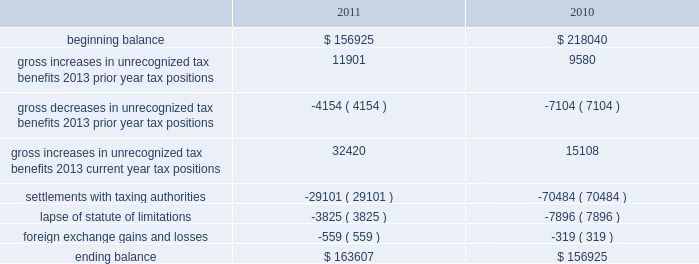A valuation allowance has been established for certain deferred tax assets related to the impairment of investments .
Accounting for uncertainty in income taxes during fiscal 2011 and 2010 , our aggregate changes in our total gross amount of unrecognized tax benefits are summarized as follows ( in thousands ) : beginning balance gross increases in unrecognized tax benefits 2013 prior year tax positions gross decreases in unrecognized tax benefits 2013 prior year tax positions gross increases in unrecognized tax benefits 2013 current year tax positions settlements with taxing authorities lapse of statute of limitations foreign exchange gains and losses ending balance $ 156925 11901 ( 4154 ) 32420 ( 29101 ) ( 3825 ) $ 163607 $ 218040 ( 7104 ) 15108 ( 70484 ) ( 7896 ) $ 156925 as of december 2 , 2011 , the combined amount of accrued interest and penalties related to tax positions taken on our tax returns and included in non-current income taxes payable was approximately $ 12.3 million .
We file income tax returns in the u.s .
On a federal basis and in many u.s .
State and foreign jurisdictions .
We are subject to the continual examination of our income tax returns by the irs and other domestic and foreign tax authorities .
Our major tax jurisdictions are the u.s. , ireland and california .
For california , ireland and the u.s. , the earliest fiscal years open for examination are 2005 , 2006 and 2008 , respectively .
We regularly assess the likelihood of outcomes resulting from these examinations to determine the adequacy of our provision for income taxes and have reserved for potential adjustments that may result from the current examination .
We believe such estimates to be reasonable ; however , there can be no assurance that the final determination of any of these examinations will not have an adverse effect on our operating results and financial position .
In august 2011 , a canadian income tax examination covering our fiscal years 2005 through 2008 was completed .
Our accrued tax and interest related to these years was approximately $ 35 million and was previously reported in long-term income taxes payable .
We reclassified approximately $ 17 million to short-term income taxes payable and decreased deferred tax assets by approximately $ 18 million in conjunction with the aforementioned resolution .
The $ 17 million balance in short-term income taxes payable is partially secured by a letter of credit and is expected to be paid by the first quarter of fiscal 2012 .
In october 2010 , a u.s .
Income tax examination covering our fiscal years 2005 through 2007 was completed .
Our accrued tax and interest related to these years was $ 59 million and was previously reported in long-term income taxes payable .
We paid $ 20 million in conjunction with the aforementioned resolution .
A net income statement tax benefit in the fourth quarter of fiscal 2010 of $ 39 million resulted .
The timing of the resolution of income tax examinations is highly uncertain as are the amounts and timing of tax payments that are part of any audit settlement process .
These events could cause large fluctuations in the balance sheet classification of current and non-current assets and liabilities .
The company believes that before the end of fiscal 2012 , it is reasonably possible that either certain audits will conclude or statutes of limitations on certain income tax examination periods will expire , or both .
Given the uncertainties described above , we can only determine a range of estimated potential decreases in underlying unrecognized tax benefits ranging from $ 0 to approximately $ 40 million .
These amounts would decrease income tax expense under current gaap related to income taxes .
Note 11 .
Restructuring fiscal 2011 restructuring plan in the fourth quarter of fiscal 2011 , in order to better align our resources around our digital media and digital marketing strategies , we initiated a restructuring plan consisting of reductions of approximately 700 full-time positions worldwide and we recorded restructuring charges of approximately $ 78.6 million related to ongoing termination benefits for the position eliminated .
Table of contents adobe systems incorporated notes to consolidated financial statements ( continued ) .
A valuation allowance has been established for certain deferred tax assets related to the impairment of investments .
Accounting for uncertainty in income taxes during fiscal 2011 and 2010 , our aggregate changes in our total gross amount of unrecognized tax benefits are summarized as follows ( in thousands ) : beginning balance gross increases in unrecognized tax benefits 2013 prior year tax positions gross decreases in unrecognized tax benefits 2013 prior year tax positions gross increases in unrecognized tax benefits 2013 current year tax positions settlements with taxing authorities lapse of statute of limitations foreign exchange gains and losses ending balance $ 156925 11901 ( 4154 ) 32420 ( 29101 ) ( 3825 ) $ 163607 $ 218040 ( 7104 ) 15108 ( 70484 ) ( 7896 ) $ 156925 as of december 2 , 2011 , the combined amount of accrued interest and penalties related to tax positions taken on our tax returns and included in non-current income taxes payable was approximately $ 12.3 million .
We file income tax returns in the u.s .
On a federal basis and in many u.s .
State and foreign jurisdictions .
We are subject to the continual examination of our income tax returns by the irs and other domestic and foreign tax authorities .
Our major tax jurisdictions are the u.s. , ireland and california .
For california , ireland and the u.s. , the earliest fiscal years open for examination are 2005 , 2006 and 2008 , respectively .
We regularly assess the likelihood of outcomes resulting from these examinations to determine the adequacy of our provision for income taxes and have reserved for potential adjustments that may result from the current examination .
We believe such estimates to be reasonable ; however , there can be no assurance that the final determination of any of these examinations will not have an adverse effect on our operating results and financial position .
In august 2011 , a canadian income tax examination covering our fiscal years 2005 through 2008 was completed .
Our accrued tax and interest related to these years was approximately $ 35 million and was previously reported in long-term income taxes payable .
We reclassified approximately $ 17 million to short-term income taxes payable and decreased deferred tax assets by approximately $ 18 million in conjunction with the aforementioned resolution .
The $ 17 million balance in short-term income taxes payable is partially secured by a letter of credit and is expected to be paid by the first quarter of fiscal 2012 .
In october 2010 , a u.s .
Income tax examination covering our fiscal years 2005 through 2007 was completed .
Our accrued tax and interest related to these years was $ 59 million and was previously reported in long-term income taxes payable .
We paid $ 20 million in conjunction with the aforementioned resolution .
A net income statement tax benefit in the fourth quarter of fiscal 2010 of $ 39 million resulted .
The timing of the resolution of income tax examinations is highly uncertain as are the amounts and timing of tax payments that are part of any audit settlement process .
These events could cause large fluctuations in the balance sheet classification of current and non-current assets and liabilities .
The company believes that before the end of fiscal 2012 , it is reasonably possible that either certain audits will conclude or statutes of limitations on certain income tax examination periods will expire , or both .
Given the uncertainties described above , we can only determine a range of estimated potential decreases in underlying unrecognized tax benefits ranging from $ 0 to approximately $ 40 million .
These amounts would decrease income tax expense under current gaap related to income taxes .
Note 11 .
Restructuring fiscal 2011 restructuring plan in the fourth quarter of fiscal 2011 , in order to better align our resources around our digital media and digital marketing strategies , we initiated a restructuring plan consisting of reductions of approximately 700 full-time positions worldwide and we recorded restructuring charges of approximately $ 78.6 million related to ongoing termination benefits for the position eliminated .
Table of contents adobe systems incorporated notes to consolidated financial statements ( continued ) .
What is the growth rate in the balance of unrecognized tax benefits during 2011? 
Computations: ((163607 - 156925) / 156925)
Answer: 0.04258. 